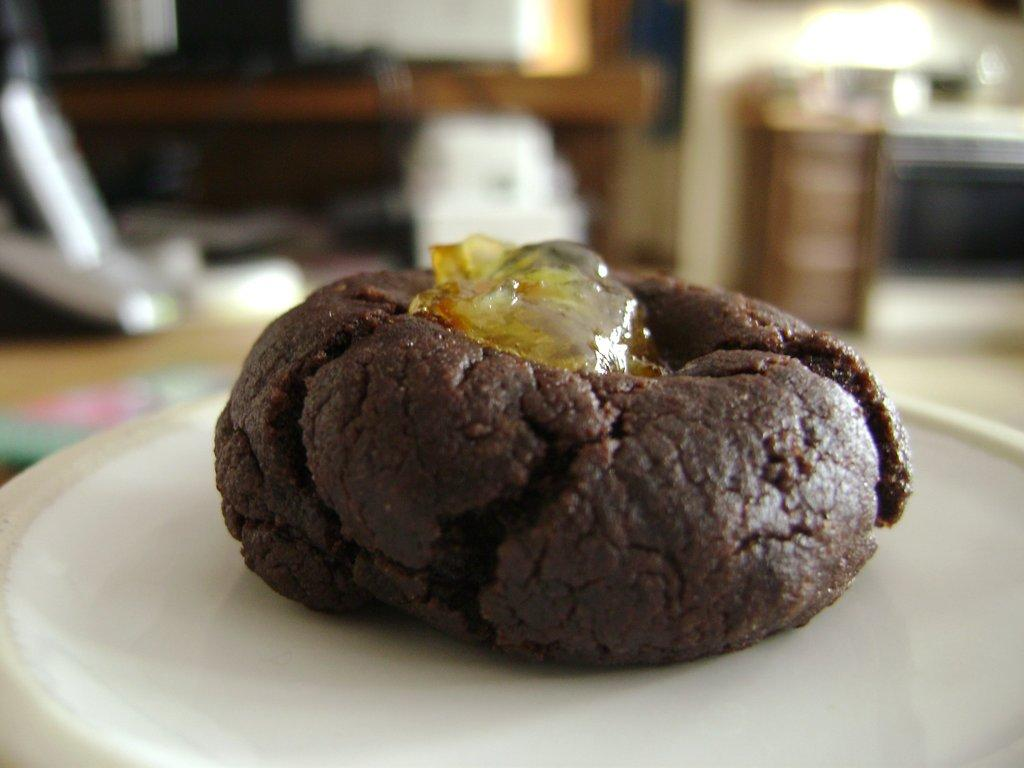What is on the plate in the image? There is a food item on a plate in the image. Can you describe the background of the image? The background of the image is blurred, but objects and a wall are visible. What type of surface is present in the background of the image? There is a floor in the background of the image. What type of brush is being used by the snail on the throne in the image? There is no snail or throne present in the image; it only features a food item on a plate with a blurred background. 